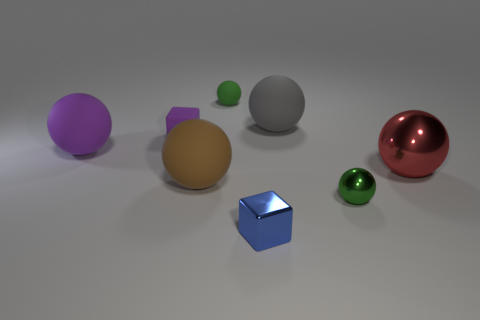What is the material of the other sphere that is the same color as the small metal sphere?
Keep it short and to the point. Rubber. There is a green object behind the red metallic sphere; is it the same size as the purple ball that is left of the gray object?
Provide a short and direct response. No. The green thing in front of the big gray rubber sphere has what shape?
Offer a terse response. Sphere. There is another tiny thing that is the same shape as the green rubber thing; what is it made of?
Provide a succinct answer. Metal. There is a green ball behind the brown sphere; does it have the same size as the red ball?
Provide a succinct answer. No. There is a big brown thing; how many small purple things are right of it?
Ensure brevity in your answer.  0. Are there fewer large red metal objects that are behind the blue object than cubes behind the big gray rubber ball?
Your answer should be compact. No. What number of large gray objects are there?
Offer a terse response. 1. What color is the big rubber ball in front of the large purple rubber sphere?
Provide a short and direct response. Brown. What size is the gray rubber object?
Make the answer very short. Large. 